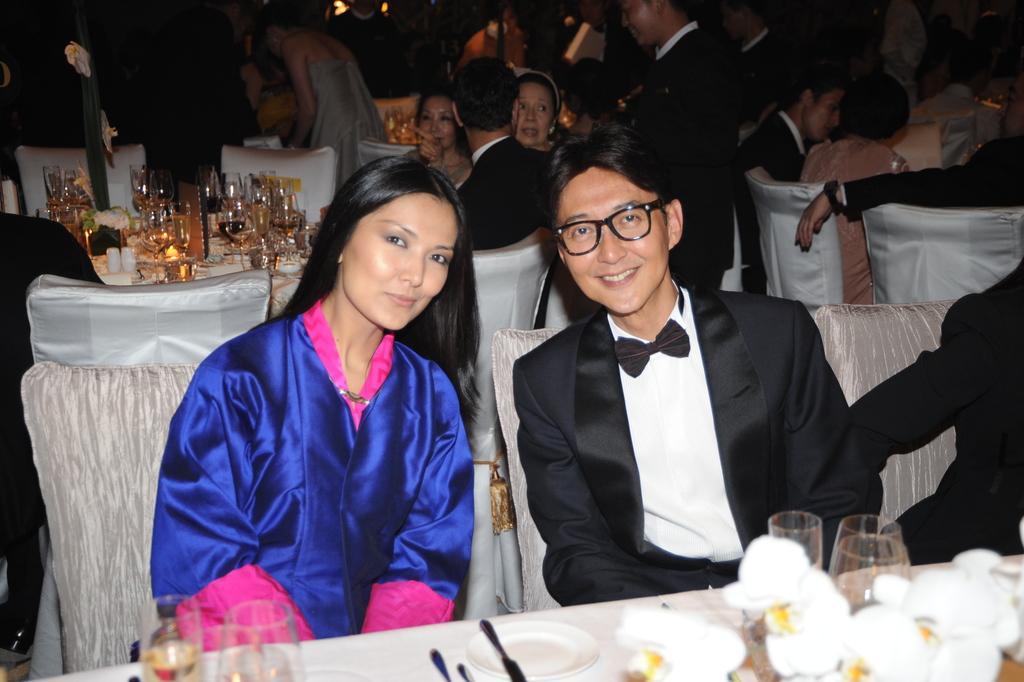How would you summarize this image in a sentence or two? In a room there are so many people sitting on a chairs in front of table and there are so many glass arranged with drinks and food on table. 